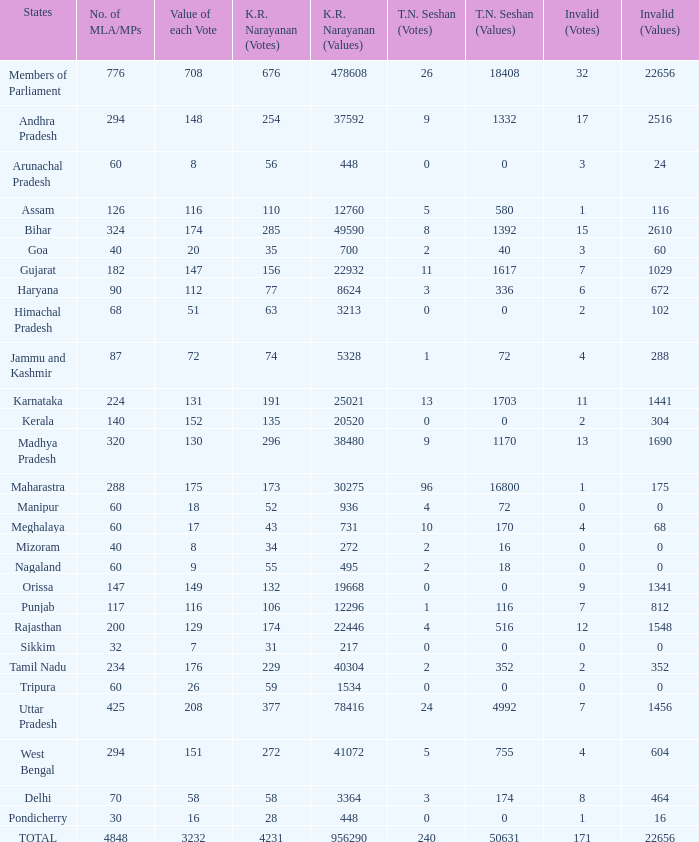Specify the count of tn seshan values when kr values are 47860 1.0. 